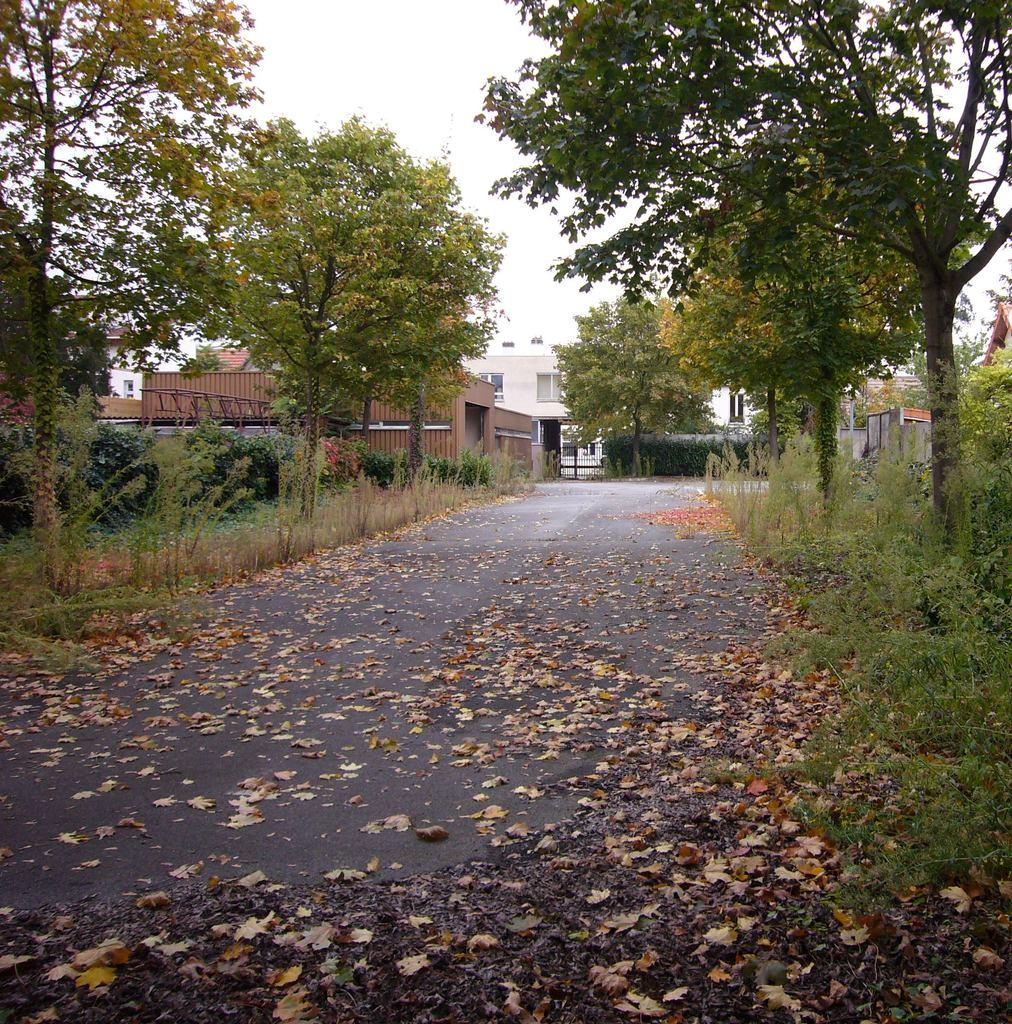What can be seen on the path in the foreground of the image? There are dry leaves on the path in the foreground area of the image. What is visible in the background of the image? There are trees, plants, houses, and the sky visible in the background of the image. How does the foot of the person in the image create friction with the dry leaves? There is no person present in the image, so it is not possible to determine how a foot might interact with the dry leaves. 